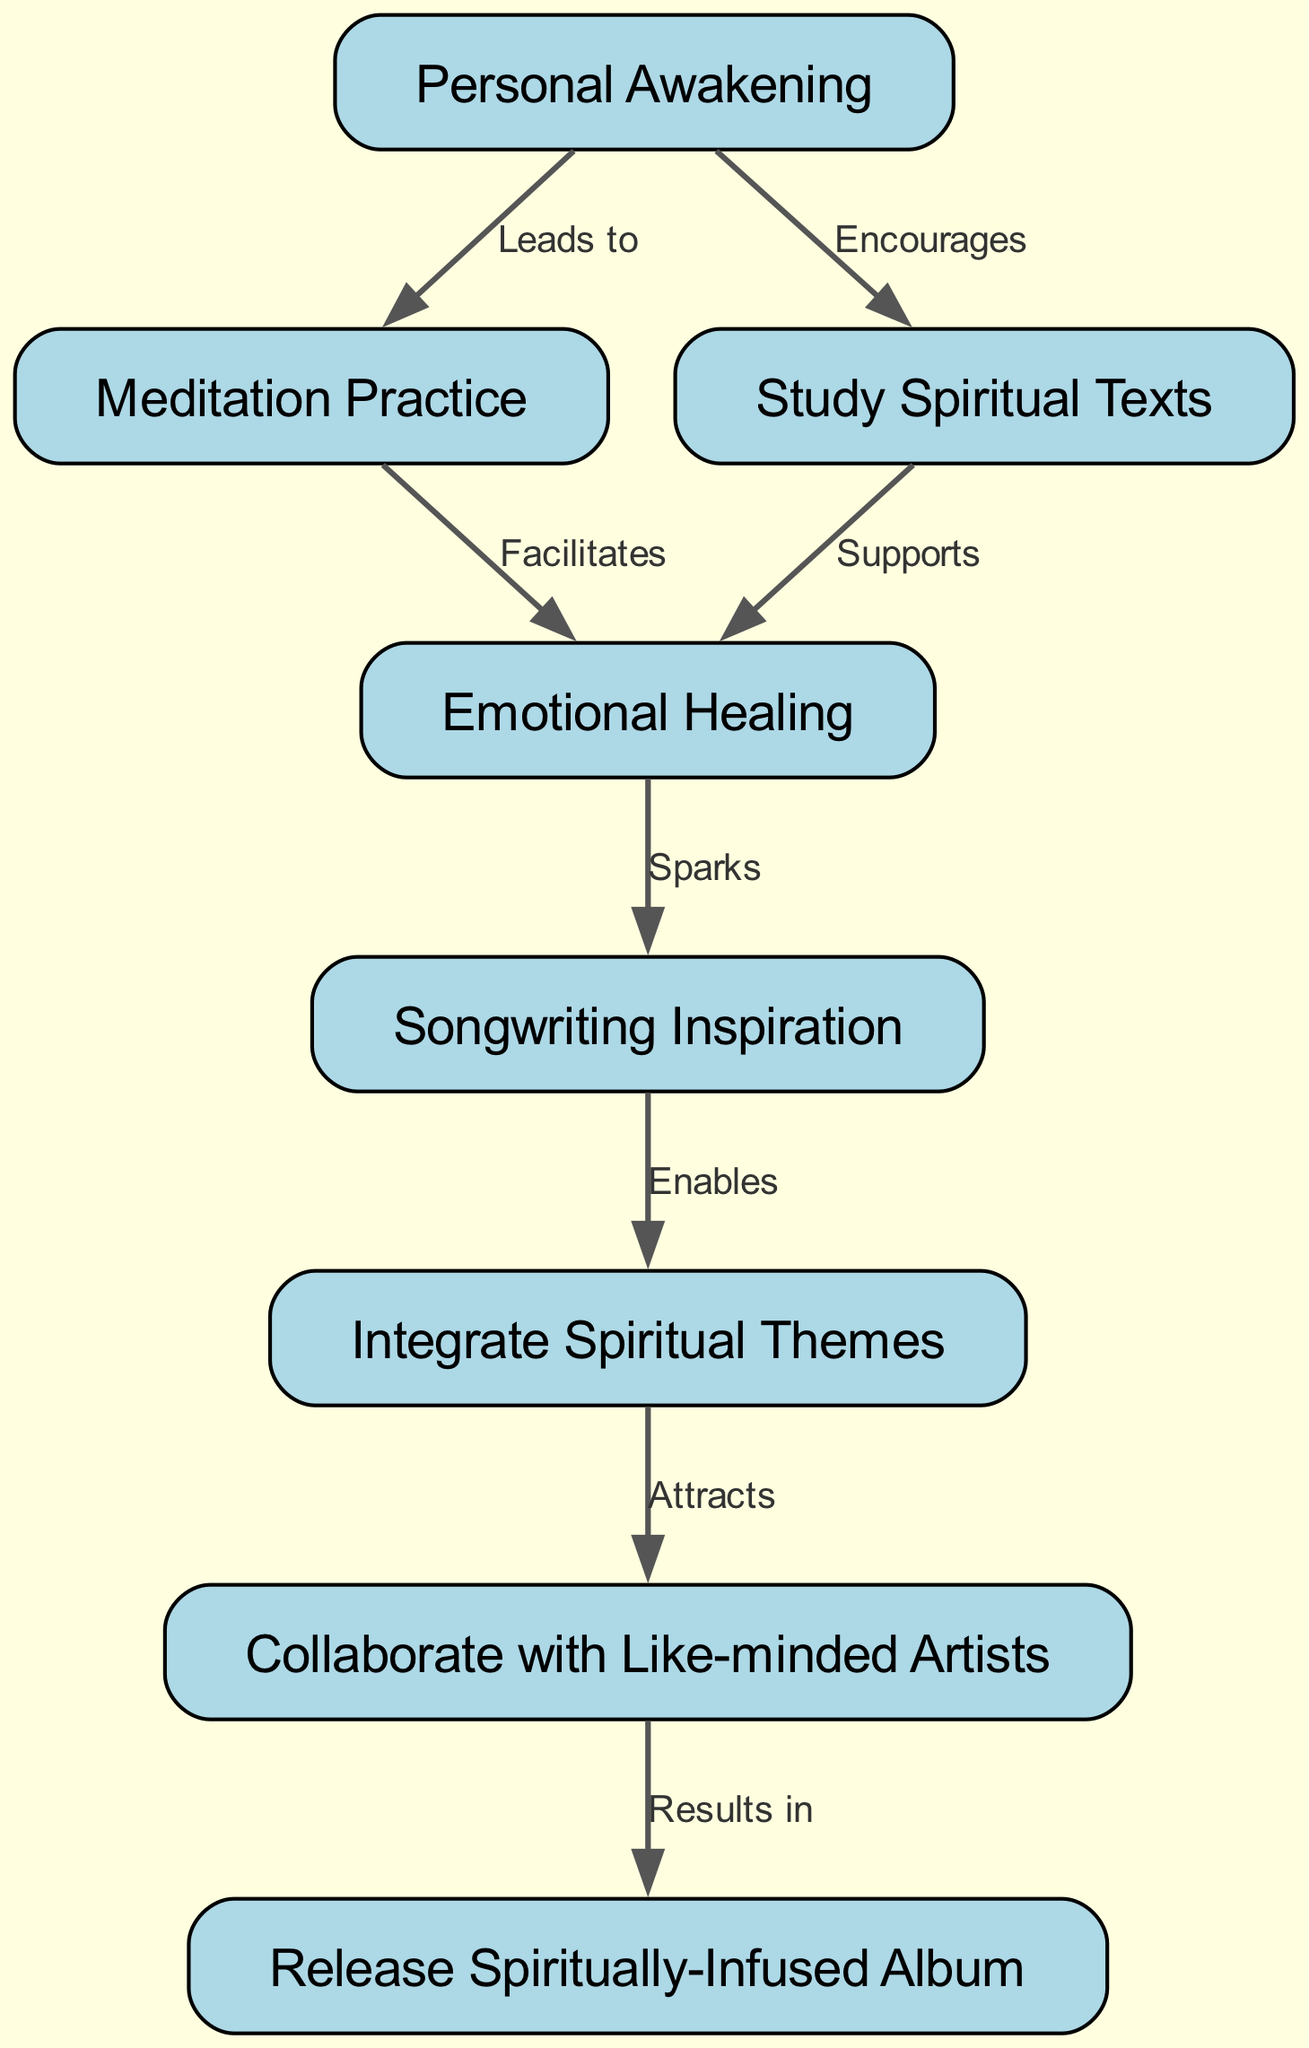What is the first step in the journey of personal spiritual growth? The diagram starts with the node labeled "Personal Awakening," indicating that this is the initial step in the journey.
Answer: Personal Awakening How many nodes are in the diagram? By counting the nodes listed in the provided data, there are a total of eight nodes.
Answer: 8 What relationship connects "Meditation Practice" and "Emotional Healing"? The diagram indicates that "Meditation Practice" facilitates "Emotional Healing," showing a direct relationship between these two nodes.
Answer: Facilitates Which node leads to "Songwriting Inspiration"? The edge from "Emotional Healing" to "Songwriting Inspiration" indicates that "Emotional Healing" sparks the inspiration to create songs.
Answer: Emotional Healing How does one attract collaboration according to the flow? To attract collaboration, one must integrate spiritual themes into their music, as indicated by the edge from "Integrate Spiritual Themes" to "Collaborate with Like-minded Artists."
Answer: Integrate Spiritual Themes What is the final outcome of collaborating with like-minded artists? The flow shows that collaborating with like-minded artists results in the release of a spiritually-infused album, as depicted in the last edge of the diagram.
Answer: Release Spiritually-Infused Album Which two practices support emotional healing? Both "Meditation Practice" and "Study Spiritual Texts" connect to "Emotional Healing," indicating they both support this aspect of personal growth.
Answer: Meditation Practice, Study Spiritual Texts How do spiritual themes facilitate creativity in songwriting? Spiritual themes enable songwriting inspiration, as shown by the edge connecting "Songwriting Inspiration" to "Integrate Spiritual Themes," which suggests that integrating these themes directly impacts creativity.
Answer: Enables What two steps come after personal awakening? After "Personal Awakening," the next two steps are "Meditation Practice" and "Study Spiritual Texts," both of which lead to further growth.
Answer: Meditation Practice, Study Spiritual Texts 